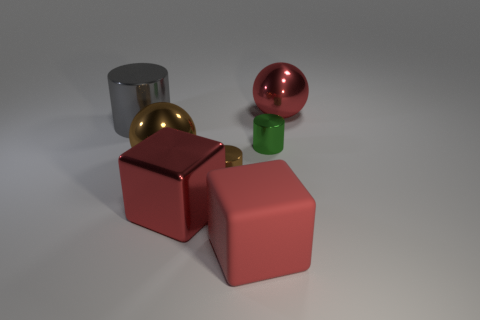Subtract all big cylinders. How many cylinders are left? 2 Subtract all gray cylinders. How many cylinders are left? 2 Add 1 large purple shiny objects. How many objects exist? 8 Subtract 1 brown cylinders. How many objects are left? 6 Subtract all blocks. How many objects are left? 5 Subtract 2 blocks. How many blocks are left? 0 Subtract all red balls. Subtract all purple cylinders. How many balls are left? 1 Subtract all green balls. How many brown cylinders are left? 1 Subtract all cyan shiny blocks. Subtract all tiny green cylinders. How many objects are left? 6 Add 6 big red blocks. How many big red blocks are left? 8 